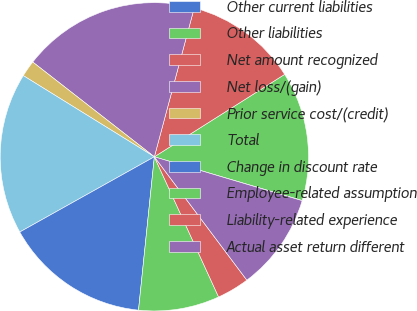Convert chart to OTSL. <chart><loc_0><loc_0><loc_500><loc_500><pie_chart><fcel>Other current liabilities<fcel>Other liabilities<fcel>Net amount recognized<fcel>Net loss/(gain)<fcel>Prior service cost/(credit)<fcel>Total<fcel>Change in discount rate<fcel>Employee-related assumption<fcel>Liability-related experience<fcel>Actual asset return different<nl><fcel>0.02%<fcel>13.55%<fcel>11.86%<fcel>18.63%<fcel>1.71%<fcel>16.94%<fcel>15.25%<fcel>8.48%<fcel>3.4%<fcel>10.17%<nl></chart> 